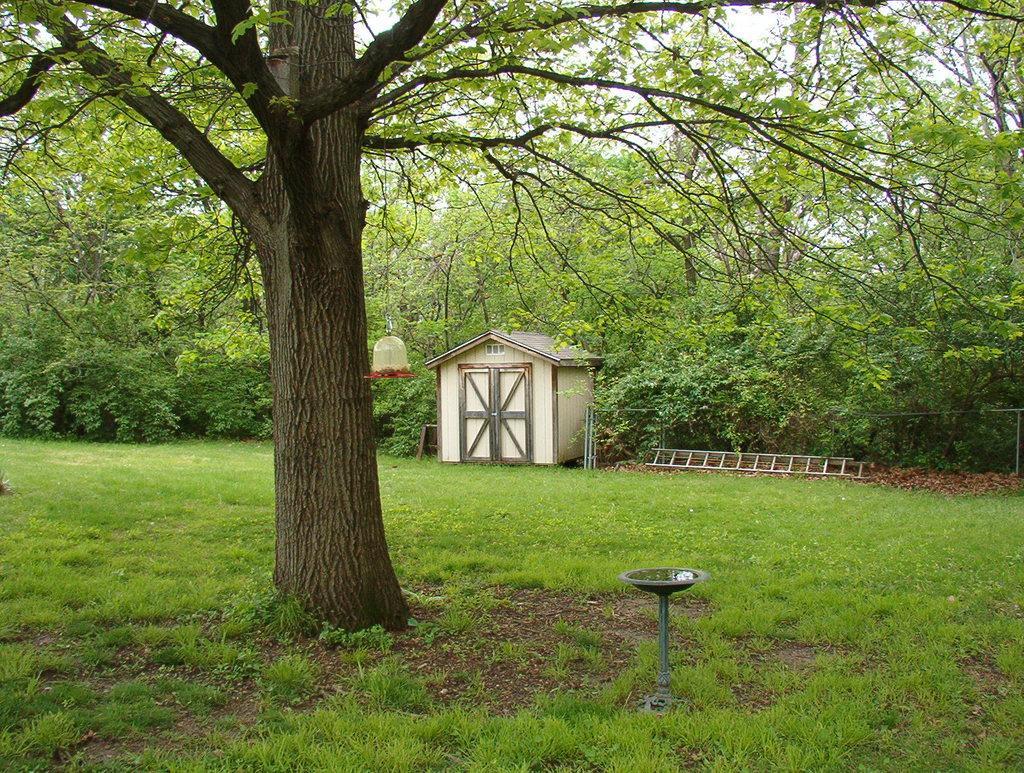Describe this image in one or two sentences. In the picture we can see a grass surface on it we can see a tree and some far away we can see a hut with doors and beside it we can see a ;adder placed on the surface and behind the hut we can see many trees and a part of the sky from it. 